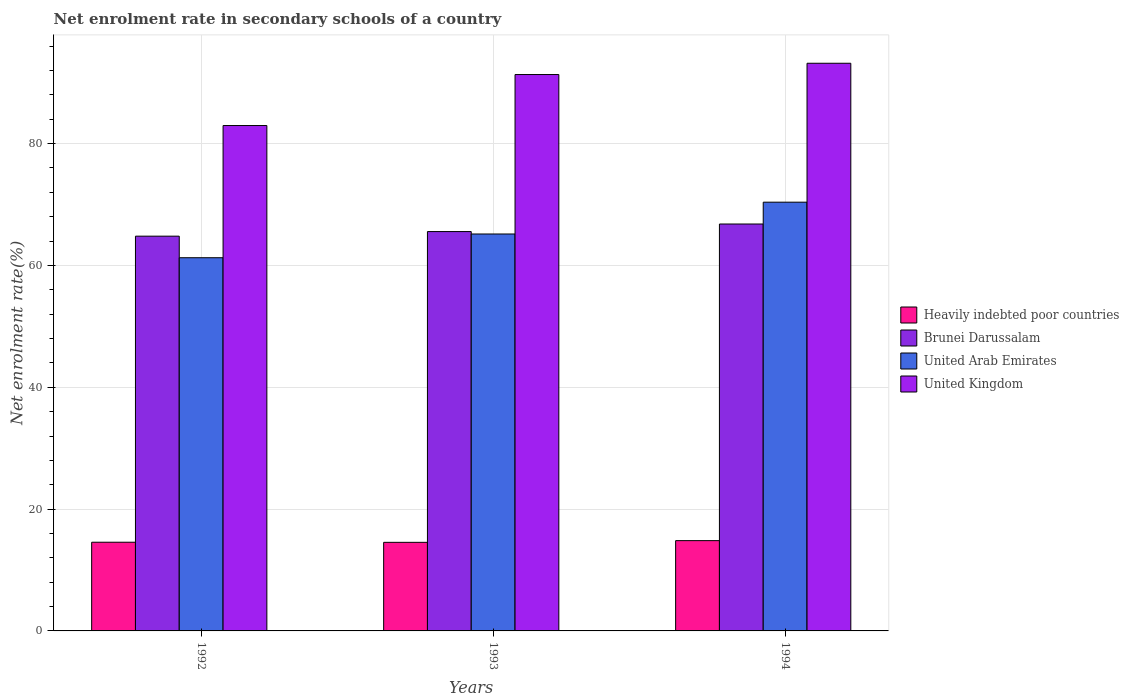How many groups of bars are there?
Your answer should be very brief. 3. Are the number of bars per tick equal to the number of legend labels?
Your answer should be compact. Yes. How many bars are there on the 1st tick from the right?
Offer a very short reply. 4. What is the net enrolment rate in secondary schools in Brunei Darussalam in 1992?
Make the answer very short. 64.81. Across all years, what is the maximum net enrolment rate in secondary schools in Brunei Darussalam?
Provide a short and direct response. 66.8. Across all years, what is the minimum net enrolment rate in secondary schools in Heavily indebted poor countries?
Give a very brief answer. 14.54. In which year was the net enrolment rate in secondary schools in Brunei Darussalam maximum?
Give a very brief answer. 1994. What is the total net enrolment rate in secondary schools in Brunei Darussalam in the graph?
Provide a succinct answer. 197.18. What is the difference between the net enrolment rate in secondary schools in Brunei Darussalam in 1992 and that in 1993?
Keep it short and to the point. -0.75. What is the difference between the net enrolment rate in secondary schools in Heavily indebted poor countries in 1992 and the net enrolment rate in secondary schools in Brunei Darussalam in 1994?
Make the answer very short. -52.24. What is the average net enrolment rate in secondary schools in United Arab Emirates per year?
Provide a succinct answer. 65.61. In the year 1993, what is the difference between the net enrolment rate in secondary schools in Heavily indebted poor countries and net enrolment rate in secondary schools in United Arab Emirates?
Ensure brevity in your answer.  -50.62. In how many years, is the net enrolment rate in secondary schools in Brunei Darussalam greater than 12 %?
Make the answer very short. 3. What is the ratio of the net enrolment rate in secondary schools in United Kingdom in 1992 to that in 1993?
Ensure brevity in your answer.  0.91. Is the difference between the net enrolment rate in secondary schools in Heavily indebted poor countries in 1993 and 1994 greater than the difference between the net enrolment rate in secondary schools in United Arab Emirates in 1993 and 1994?
Give a very brief answer. Yes. What is the difference between the highest and the second highest net enrolment rate in secondary schools in Heavily indebted poor countries?
Your answer should be very brief. 0.26. What is the difference between the highest and the lowest net enrolment rate in secondary schools in United Arab Emirates?
Your response must be concise. 9.12. In how many years, is the net enrolment rate in secondary schools in Heavily indebted poor countries greater than the average net enrolment rate in secondary schools in Heavily indebted poor countries taken over all years?
Your answer should be very brief. 1. Is the sum of the net enrolment rate in secondary schools in Brunei Darussalam in 1992 and 1994 greater than the maximum net enrolment rate in secondary schools in United Arab Emirates across all years?
Make the answer very short. Yes. What does the 3rd bar from the left in 1993 represents?
Ensure brevity in your answer.  United Arab Emirates. How many bars are there?
Provide a short and direct response. 12. Are all the bars in the graph horizontal?
Your response must be concise. No. How many years are there in the graph?
Keep it short and to the point. 3. What is the difference between two consecutive major ticks on the Y-axis?
Provide a short and direct response. 20. How are the legend labels stacked?
Make the answer very short. Vertical. What is the title of the graph?
Provide a succinct answer. Net enrolment rate in secondary schools of a country. Does "France" appear as one of the legend labels in the graph?
Offer a very short reply. No. What is the label or title of the Y-axis?
Your response must be concise. Net enrolment rate(%). What is the Net enrolment rate(%) in Heavily indebted poor countries in 1992?
Your answer should be very brief. 14.56. What is the Net enrolment rate(%) in Brunei Darussalam in 1992?
Keep it short and to the point. 64.81. What is the Net enrolment rate(%) in United Arab Emirates in 1992?
Provide a short and direct response. 61.27. What is the Net enrolment rate(%) of United Kingdom in 1992?
Offer a terse response. 82.97. What is the Net enrolment rate(%) in Heavily indebted poor countries in 1993?
Your answer should be compact. 14.54. What is the Net enrolment rate(%) of Brunei Darussalam in 1993?
Give a very brief answer. 65.56. What is the Net enrolment rate(%) of United Arab Emirates in 1993?
Offer a very short reply. 65.16. What is the Net enrolment rate(%) of United Kingdom in 1993?
Provide a succinct answer. 91.34. What is the Net enrolment rate(%) of Heavily indebted poor countries in 1994?
Your answer should be very brief. 14.82. What is the Net enrolment rate(%) of Brunei Darussalam in 1994?
Make the answer very short. 66.8. What is the Net enrolment rate(%) in United Arab Emirates in 1994?
Offer a very short reply. 70.39. What is the Net enrolment rate(%) of United Kingdom in 1994?
Give a very brief answer. 93.19. Across all years, what is the maximum Net enrolment rate(%) of Heavily indebted poor countries?
Offer a very short reply. 14.82. Across all years, what is the maximum Net enrolment rate(%) of Brunei Darussalam?
Offer a terse response. 66.8. Across all years, what is the maximum Net enrolment rate(%) in United Arab Emirates?
Provide a succinct answer. 70.39. Across all years, what is the maximum Net enrolment rate(%) in United Kingdom?
Your answer should be compact. 93.19. Across all years, what is the minimum Net enrolment rate(%) of Heavily indebted poor countries?
Your answer should be compact. 14.54. Across all years, what is the minimum Net enrolment rate(%) in Brunei Darussalam?
Keep it short and to the point. 64.81. Across all years, what is the minimum Net enrolment rate(%) in United Arab Emirates?
Provide a succinct answer. 61.27. Across all years, what is the minimum Net enrolment rate(%) in United Kingdom?
Your answer should be very brief. 82.97. What is the total Net enrolment rate(%) of Heavily indebted poor countries in the graph?
Give a very brief answer. 43.93. What is the total Net enrolment rate(%) of Brunei Darussalam in the graph?
Offer a very short reply. 197.18. What is the total Net enrolment rate(%) of United Arab Emirates in the graph?
Make the answer very short. 196.82. What is the total Net enrolment rate(%) in United Kingdom in the graph?
Give a very brief answer. 267.51. What is the difference between the Net enrolment rate(%) of Heavily indebted poor countries in 1992 and that in 1993?
Give a very brief answer. 0.02. What is the difference between the Net enrolment rate(%) in Brunei Darussalam in 1992 and that in 1993?
Provide a succinct answer. -0.75. What is the difference between the Net enrolment rate(%) in United Arab Emirates in 1992 and that in 1993?
Your answer should be compact. -3.9. What is the difference between the Net enrolment rate(%) of United Kingdom in 1992 and that in 1993?
Your response must be concise. -8.37. What is the difference between the Net enrolment rate(%) of Heavily indebted poor countries in 1992 and that in 1994?
Offer a terse response. -0.26. What is the difference between the Net enrolment rate(%) of Brunei Darussalam in 1992 and that in 1994?
Give a very brief answer. -1.99. What is the difference between the Net enrolment rate(%) of United Arab Emirates in 1992 and that in 1994?
Your response must be concise. -9.12. What is the difference between the Net enrolment rate(%) in United Kingdom in 1992 and that in 1994?
Ensure brevity in your answer.  -10.22. What is the difference between the Net enrolment rate(%) of Heavily indebted poor countries in 1993 and that in 1994?
Keep it short and to the point. -0.28. What is the difference between the Net enrolment rate(%) in Brunei Darussalam in 1993 and that in 1994?
Offer a terse response. -1.24. What is the difference between the Net enrolment rate(%) in United Arab Emirates in 1993 and that in 1994?
Your answer should be very brief. -5.22. What is the difference between the Net enrolment rate(%) in United Kingdom in 1993 and that in 1994?
Keep it short and to the point. -1.85. What is the difference between the Net enrolment rate(%) of Heavily indebted poor countries in 1992 and the Net enrolment rate(%) of Brunei Darussalam in 1993?
Give a very brief answer. -51. What is the difference between the Net enrolment rate(%) in Heavily indebted poor countries in 1992 and the Net enrolment rate(%) in United Arab Emirates in 1993?
Your answer should be very brief. -50.6. What is the difference between the Net enrolment rate(%) of Heavily indebted poor countries in 1992 and the Net enrolment rate(%) of United Kingdom in 1993?
Offer a very short reply. -76.78. What is the difference between the Net enrolment rate(%) in Brunei Darussalam in 1992 and the Net enrolment rate(%) in United Arab Emirates in 1993?
Make the answer very short. -0.36. What is the difference between the Net enrolment rate(%) of Brunei Darussalam in 1992 and the Net enrolment rate(%) of United Kingdom in 1993?
Your answer should be compact. -26.53. What is the difference between the Net enrolment rate(%) in United Arab Emirates in 1992 and the Net enrolment rate(%) in United Kingdom in 1993?
Offer a terse response. -30.08. What is the difference between the Net enrolment rate(%) in Heavily indebted poor countries in 1992 and the Net enrolment rate(%) in Brunei Darussalam in 1994?
Keep it short and to the point. -52.24. What is the difference between the Net enrolment rate(%) of Heavily indebted poor countries in 1992 and the Net enrolment rate(%) of United Arab Emirates in 1994?
Your response must be concise. -55.83. What is the difference between the Net enrolment rate(%) of Heavily indebted poor countries in 1992 and the Net enrolment rate(%) of United Kingdom in 1994?
Offer a terse response. -78.63. What is the difference between the Net enrolment rate(%) of Brunei Darussalam in 1992 and the Net enrolment rate(%) of United Arab Emirates in 1994?
Ensure brevity in your answer.  -5.58. What is the difference between the Net enrolment rate(%) of Brunei Darussalam in 1992 and the Net enrolment rate(%) of United Kingdom in 1994?
Keep it short and to the point. -28.39. What is the difference between the Net enrolment rate(%) in United Arab Emirates in 1992 and the Net enrolment rate(%) in United Kingdom in 1994?
Offer a terse response. -31.93. What is the difference between the Net enrolment rate(%) in Heavily indebted poor countries in 1993 and the Net enrolment rate(%) in Brunei Darussalam in 1994?
Your answer should be compact. -52.26. What is the difference between the Net enrolment rate(%) in Heavily indebted poor countries in 1993 and the Net enrolment rate(%) in United Arab Emirates in 1994?
Offer a very short reply. -55.84. What is the difference between the Net enrolment rate(%) of Heavily indebted poor countries in 1993 and the Net enrolment rate(%) of United Kingdom in 1994?
Your answer should be compact. -78.65. What is the difference between the Net enrolment rate(%) of Brunei Darussalam in 1993 and the Net enrolment rate(%) of United Arab Emirates in 1994?
Ensure brevity in your answer.  -4.83. What is the difference between the Net enrolment rate(%) in Brunei Darussalam in 1993 and the Net enrolment rate(%) in United Kingdom in 1994?
Provide a short and direct response. -27.63. What is the difference between the Net enrolment rate(%) of United Arab Emirates in 1993 and the Net enrolment rate(%) of United Kingdom in 1994?
Your response must be concise. -28.03. What is the average Net enrolment rate(%) of Heavily indebted poor countries per year?
Your response must be concise. 14.64. What is the average Net enrolment rate(%) of Brunei Darussalam per year?
Keep it short and to the point. 65.72. What is the average Net enrolment rate(%) of United Arab Emirates per year?
Give a very brief answer. 65.61. What is the average Net enrolment rate(%) of United Kingdom per year?
Offer a terse response. 89.17. In the year 1992, what is the difference between the Net enrolment rate(%) in Heavily indebted poor countries and Net enrolment rate(%) in Brunei Darussalam?
Your response must be concise. -50.25. In the year 1992, what is the difference between the Net enrolment rate(%) in Heavily indebted poor countries and Net enrolment rate(%) in United Arab Emirates?
Your answer should be very brief. -46.71. In the year 1992, what is the difference between the Net enrolment rate(%) in Heavily indebted poor countries and Net enrolment rate(%) in United Kingdom?
Give a very brief answer. -68.41. In the year 1992, what is the difference between the Net enrolment rate(%) of Brunei Darussalam and Net enrolment rate(%) of United Arab Emirates?
Provide a short and direct response. 3.54. In the year 1992, what is the difference between the Net enrolment rate(%) of Brunei Darussalam and Net enrolment rate(%) of United Kingdom?
Make the answer very short. -18.16. In the year 1992, what is the difference between the Net enrolment rate(%) of United Arab Emirates and Net enrolment rate(%) of United Kingdom?
Offer a very short reply. -21.7. In the year 1993, what is the difference between the Net enrolment rate(%) in Heavily indebted poor countries and Net enrolment rate(%) in Brunei Darussalam?
Your response must be concise. -51.02. In the year 1993, what is the difference between the Net enrolment rate(%) in Heavily indebted poor countries and Net enrolment rate(%) in United Arab Emirates?
Provide a succinct answer. -50.62. In the year 1993, what is the difference between the Net enrolment rate(%) of Heavily indebted poor countries and Net enrolment rate(%) of United Kingdom?
Offer a very short reply. -76.8. In the year 1993, what is the difference between the Net enrolment rate(%) of Brunei Darussalam and Net enrolment rate(%) of United Arab Emirates?
Ensure brevity in your answer.  0.4. In the year 1993, what is the difference between the Net enrolment rate(%) in Brunei Darussalam and Net enrolment rate(%) in United Kingdom?
Your answer should be very brief. -25.78. In the year 1993, what is the difference between the Net enrolment rate(%) in United Arab Emirates and Net enrolment rate(%) in United Kingdom?
Offer a very short reply. -26.18. In the year 1994, what is the difference between the Net enrolment rate(%) in Heavily indebted poor countries and Net enrolment rate(%) in Brunei Darussalam?
Your response must be concise. -51.98. In the year 1994, what is the difference between the Net enrolment rate(%) in Heavily indebted poor countries and Net enrolment rate(%) in United Arab Emirates?
Your answer should be compact. -55.56. In the year 1994, what is the difference between the Net enrolment rate(%) of Heavily indebted poor countries and Net enrolment rate(%) of United Kingdom?
Your response must be concise. -78.37. In the year 1994, what is the difference between the Net enrolment rate(%) of Brunei Darussalam and Net enrolment rate(%) of United Arab Emirates?
Your response must be concise. -3.58. In the year 1994, what is the difference between the Net enrolment rate(%) in Brunei Darussalam and Net enrolment rate(%) in United Kingdom?
Ensure brevity in your answer.  -26.39. In the year 1994, what is the difference between the Net enrolment rate(%) in United Arab Emirates and Net enrolment rate(%) in United Kingdom?
Keep it short and to the point. -22.81. What is the ratio of the Net enrolment rate(%) in Brunei Darussalam in 1992 to that in 1993?
Your response must be concise. 0.99. What is the ratio of the Net enrolment rate(%) of United Arab Emirates in 1992 to that in 1993?
Give a very brief answer. 0.94. What is the ratio of the Net enrolment rate(%) in United Kingdom in 1992 to that in 1993?
Offer a terse response. 0.91. What is the ratio of the Net enrolment rate(%) of Heavily indebted poor countries in 1992 to that in 1994?
Provide a succinct answer. 0.98. What is the ratio of the Net enrolment rate(%) of Brunei Darussalam in 1992 to that in 1994?
Keep it short and to the point. 0.97. What is the ratio of the Net enrolment rate(%) in United Arab Emirates in 1992 to that in 1994?
Offer a terse response. 0.87. What is the ratio of the Net enrolment rate(%) in United Kingdom in 1992 to that in 1994?
Your response must be concise. 0.89. What is the ratio of the Net enrolment rate(%) of Heavily indebted poor countries in 1993 to that in 1994?
Provide a short and direct response. 0.98. What is the ratio of the Net enrolment rate(%) of Brunei Darussalam in 1993 to that in 1994?
Give a very brief answer. 0.98. What is the ratio of the Net enrolment rate(%) in United Arab Emirates in 1993 to that in 1994?
Give a very brief answer. 0.93. What is the ratio of the Net enrolment rate(%) in United Kingdom in 1993 to that in 1994?
Offer a terse response. 0.98. What is the difference between the highest and the second highest Net enrolment rate(%) of Heavily indebted poor countries?
Provide a succinct answer. 0.26. What is the difference between the highest and the second highest Net enrolment rate(%) of Brunei Darussalam?
Make the answer very short. 1.24. What is the difference between the highest and the second highest Net enrolment rate(%) of United Arab Emirates?
Ensure brevity in your answer.  5.22. What is the difference between the highest and the second highest Net enrolment rate(%) of United Kingdom?
Give a very brief answer. 1.85. What is the difference between the highest and the lowest Net enrolment rate(%) of Heavily indebted poor countries?
Your answer should be very brief. 0.28. What is the difference between the highest and the lowest Net enrolment rate(%) in Brunei Darussalam?
Offer a very short reply. 1.99. What is the difference between the highest and the lowest Net enrolment rate(%) in United Arab Emirates?
Offer a terse response. 9.12. What is the difference between the highest and the lowest Net enrolment rate(%) of United Kingdom?
Give a very brief answer. 10.22. 